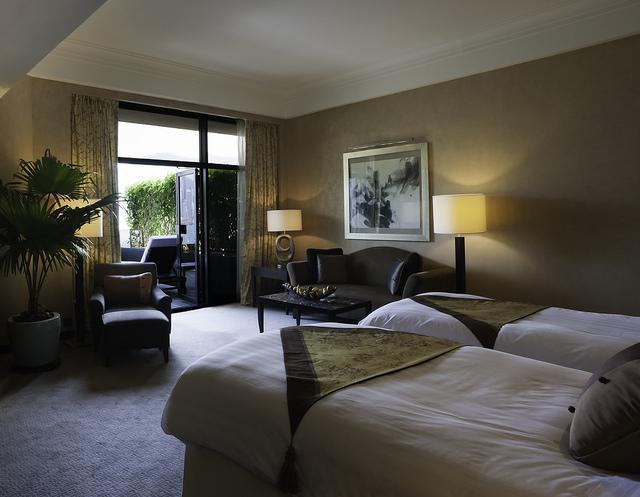What is the tray on the coffee table filled with most likely as decoration?
Make your selection from the four choices given to correctly answer the question.
Options: Fruit, candles, vegetables, blocks. Fruit. 